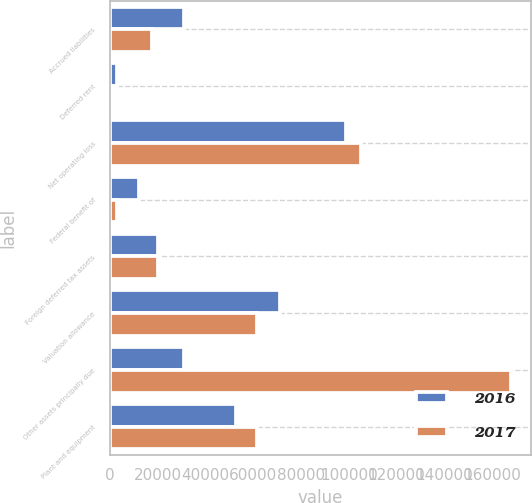Convert chart. <chart><loc_0><loc_0><loc_500><loc_500><stacked_bar_chart><ecel><fcel>Accrued liabilities<fcel>Deferred rent<fcel>Net operating loss<fcel>Federal benefit of<fcel>Foreign deferred tax assets<fcel>Valuation allowance<fcel>Other assets principally due<fcel>Plant and equipment<nl><fcel>2016<fcel>30901<fcel>2930<fcel>98879<fcel>12036<fcel>20131<fcel>71359<fcel>30901<fcel>52572<nl><fcel>2017<fcel>17565<fcel>1337<fcel>105026<fcel>3051<fcel>20029<fcel>61756<fcel>168028<fcel>61530<nl></chart> 